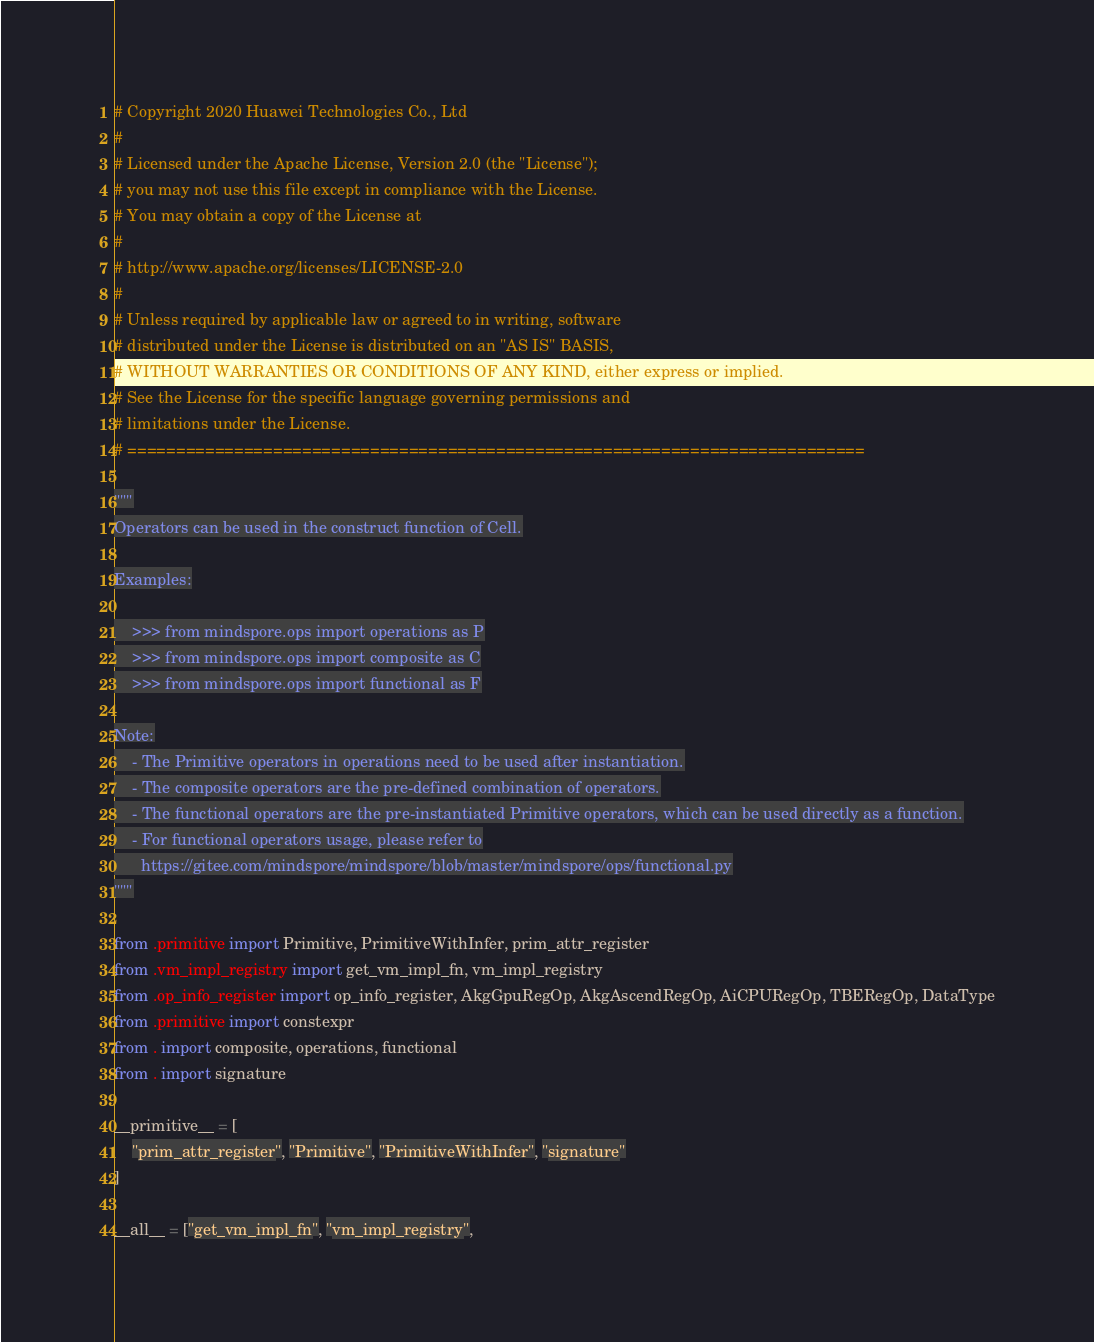<code> <loc_0><loc_0><loc_500><loc_500><_Python_># Copyright 2020 Huawei Technologies Co., Ltd
#
# Licensed under the Apache License, Version 2.0 (the "License");
# you may not use this file except in compliance with the License.
# You may obtain a copy of the License at
#
# http://www.apache.org/licenses/LICENSE-2.0
#
# Unless required by applicable law or agreed to in writing, software
# distributed under the License is distributed on an "AS IS" BASIS,
# WITHOUT WARRANTIES OR CONDITIONS OF ANY KIND, either express or implied.
# See the License for the specific language governing permissions and
# limitations under the License.
# ============================================================================

"""
Operators can be used in the construct function of Cell.

Examples:

    >>> from mindspore.ops import operations as P
    >>> from mindspore.ops import composite as C
    >>> from mindspore.ops import functional as F

Note:
    - The Primitive operators in operations need to be used after instantiation.
    - The composite operators are the pre-defined combination of operators.
    - The functional operators are the pre-instantiated Primitive operators, which can be used directly as a function.
    - For functional operators usage, please refer to
      https://gitee.com/mindspore/mindspore/blob/master/mindspore/ops/functional.py
"""

from .primitive import Primitive, PrimitiveWithInfer, prim_attr_register
from .vm_impl_registry import get_vm_impl_fn, vm_impl_registry
from .op_info_register import op_info_register, AkgGpuRegOp, AkgAscendRegOp, AiCPURegOp, TBERegOp, DataType
from .primitive import constexpr
from . import composite, operations, functional
from . import signature

__primitive__ = [
    "prim_attr_register", "Primitive", "PrimitiveWithInfer", "signature"
]

__all__ = ["get_vm_impl_fn", "vm_impl_registry",</code> 